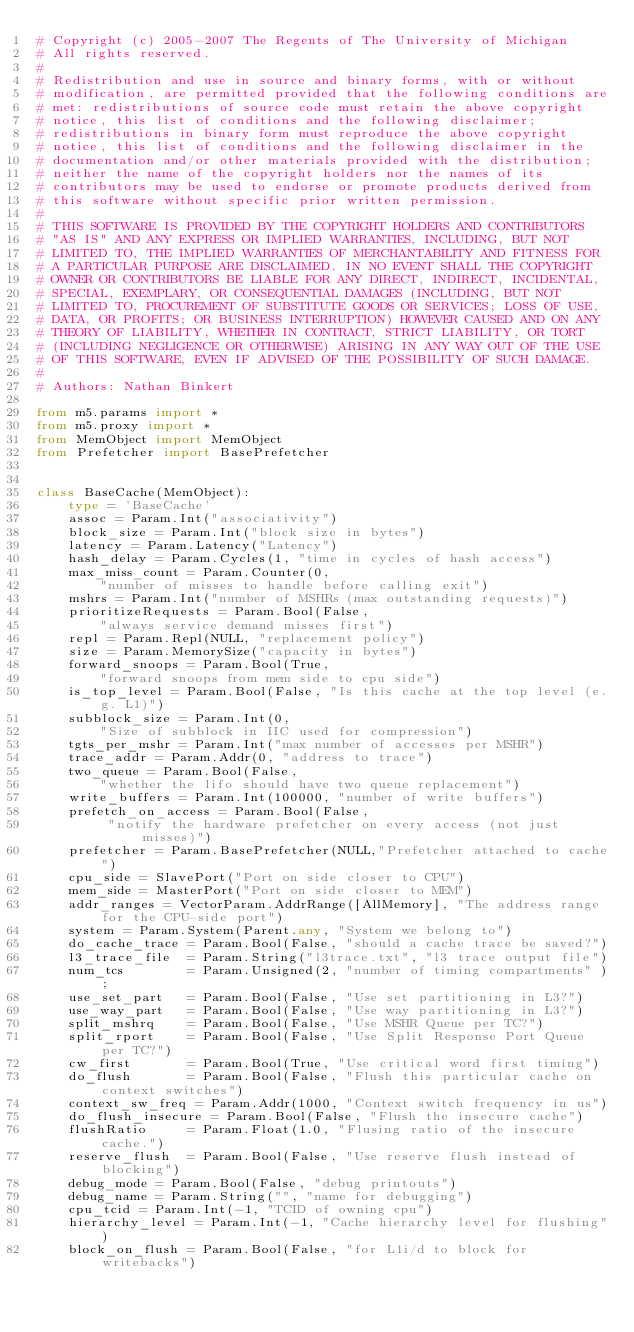<code> <loc_0><loc_0><loc_500><loc_500><_Python_># Copyright (c) 2005-2007 The Regents of The University of Michigan
# All rights reserved.
#
# Redistribution and use in source and binary forms, with or without
# modification, are permitted provided that the following conditions are
# met: redistributions of source code must retain the above copyright
# notice, this list of conditions and the following disclaimer;
# redistributions in binary form must reproduce the above copyright
# notice, this list of conditions and the following disclaimer in the
# documentation and/or other materials provided with the distribution;
# neither the name of the copyright holders nor the names of its
# contributors may be used to endorse or promote products derived from
# this software without specific prior written permission.
#
# THIS SOFTWARE IS PROVIDED BY THE COPYRIGHT HOLDERS AND CONTRIBUTORS
# "AS IS" AND ANY EXPRESS OR IMPLIED WARRANTIES, INCLUDING, BUT NOT
# LIMITED TO, THE IMPLIED WARRANTIES OF MERCHANTABILITY AND FITNESS FOR
# A PARTICULAR PURPOSE ARE DISCLAIMED. IN NO EVENT SHALL THE COPYRIGHT
# OWNER OR CONTRIBUTORS BE LIABLE FOR ANY DIRECT, INDIRECT, INCIDENTAL,
# SPECIAL, EXEMPLARY, OR CONSEQUENTIAL DAMAGES (INCLUDING, BUT NOT
# LIMITED TO, PROCUREMENT OF SUBSTITUTE GOODS OR SERVICES; LOSS OF USE,
# DATA, OR PROFITS; OR BUSINESS INTERRUPTION) HOWEVER CAUSED AND ON ANY
# THEORY OF LIABILITY, WHETHER IN CONTRACT, STRICT LIABILITY, OR TORT
# (INCLUDING NEGLIGENCE OR OTHERWISE) ARISING IN ANY WAY OUT OF THE USE
# OF THIS SOFTWARE, EVEN IF ADVISED OF THE POSSIBILITY OF SUCH DAMAGE.
#
# Authors: Nathan Binkert

from m5.params import *
from m5.proxy import *
from MemObject import MemObject
from Prefetcher import BasePrefetcher


class BaseCache(MemObject):
    type = 'BaseCache'
    assoc = Param.Int("associativity")
    block_size = Param.Int("block size in bytes")
    latency = Param.Latency("Latency")
    hash_delay = Param.Cycles(1, "time in cycles of hash access")
    max_miss_count = Param.Counter(0,
        "number of misses to handle before calling exit")
    mshrs = Param.Int("number of MSHRs (max outstanding requests)")
    prioritizeRequests = Param.Bool(False,
        "always service demand misses first")
    repl = Param.Repl(NULL, "replacement policy")
    size = Param.MemorySize("capacity in bytes")
    forward_snoops = Param.Bool(True,
        "forward snoops from mem side to cpu side")
    is_top_level = Param.Bool(False, "Is this cache at the top level (e.g. L1)")
    subblock_size = Param.Int(0,
        "Size of subblock in IIC used for compression")
    tgts_per_mshr = Param.Int("max number of accesses per MSHR")
    trace_addr = Param.Addr(0, "address to trace")
    two_queue = Param.Bool(False,
        "whether the lifo should have two queue replacement")
    write_buffers = Param.Int(100000, "number of write buffers")
    prefetch_on_access = Param.Bool(False,
         "notify the hardware prefetcher on every access (not just misses)")
    prefetcher = Param.BasePrefetcher(NULL,"Prefetcher attached to cache")
    cpu_side = SlavePort("Port on side closer to CPU")
    mem_side = MasterPort("Port on side closer to MEM")
    addr_ranges = VectorParam.AddrRange([AllMemory], "The address range for the CPU-side port")
    system = Param.System(Parent.any, "System we belong to")
    do_cache_trace = Param.Bool(False, "should a cache trace be saved?")
    l3_trace_file  = Param.String("l3trace.txt", "l3 trace output file")
    num_tcs        = Param.Unsigned(2, "number of timing compartments" );
    use_set_part   = Param.Bool(False, "Use set partitioning in L3?")
    use_way_part   = Param.Bool(False, "Use way partitioning in L3?")
    split_mshrq    = Param.Bool(False, "Use MSHR Queue per TC?")
    split_rport    = Param.Bool(False, "Use Split Response Port Queue per TC?")
    cw_first       = Param.Bool(True, "Use critical word first timing")
    do_flush       = Param.Bool(False, "Flush this particular cache on context switches")
    context_sw_freq = Param.Addr(1000, "Context switch frequency in us")
    do_flush_insecure = Param.Bool(False, "Flush the insecure cache")
    flushRatio     = Param.Float(1.0, "Flusing ratio of the insecure cache.")
    reserve_flush  = Param.Bool(False, "Use reserve flush instead of blocking")
    debug_mode = Param.Bool(False, "debug printouts")
    debug_name = Param.String("", "name for debugging")
    cpu_tcid = Param.Int(-1, "TCID of owning cpu")
    hierarchy_level = Param.Int(-1, "Cache hierarchy level for flushing")
    block_on_flush = Param.Bool(False, "for L1i/d to block for writebacks")
</code> 